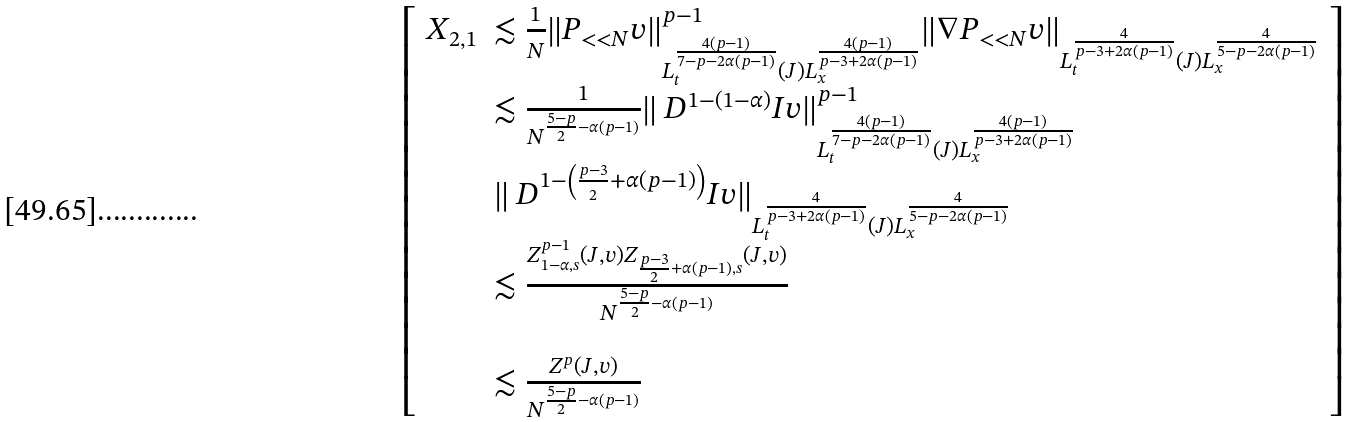Convert formula to latex. <formula><loc_0><loc_0><loc_500><loc_500>\left [ \begin{array} { l l } X _ { 2 , 1 } & \lesssim \frac { 1 } { N } \| P _ { < < N } v \| ^ { p - 1 } _ { L _ { t } ^ { \frac { 4 ( p - 1 ) } { 7 - p - 2 \alpha ( p - 1 ) } } ( J ) L _ { x } ^ { \frac { 4 ( p - 1 ) } { p - 3 + 2 \alpha ( p - 1 ) } } } \| \nabla P _ { < < N } v \| _ { L _ { t } ^ { \frac { 4 } { p - 3 + 2 \alpha ( p - 1 ) } } ( J ) L _ { x } ^ { \frac { 4 } { 5 - p - 2 \alpha ( p - 1 ) } } } \\ & \lesssim \frac { 1 } { N ^ { \frac { 5 - p } { 2 } - \alpha ( p - 1 ) } } \| \ D ^ { 1 - ( 1 - \alpha ) } I v \| ^ { p - 1 } _ { L _ { t } ^ { \frac { 4 ( p - 1 ) } { 7 - p - 2 \alpha ( p - 1 ) } } ( J ) L _ { x } ^ { \frac { 4 ( p - 1 ) } { p - 3 + 2 \alpha ( p - 1 ) } } } \\ & \| \ D ^ { 1 - \left ( \frac { p - 3 } { 2 } + \alpha ( p - 1 ) \right ) } I v \| _ { L _ { t } ^ { \frac { 4 } { p - 3 + 2 \alpha ( p - 1 ) } } ( J ) L _ { x } ^ { \frac { 4 } { 5 - p - 2 \alpha ( p - 1 ) } } } \\ & \lesssim \frac { Z ^ { p - 1 } _ { 1 - \alpha , s } ( J , v ) Z _ { \frac { p - 3 } { 2 } + \alpha ( p - 1 ) , s } ( J , v ) } { N ^ { \frac { 5 - p } { 2 } - \alpha ( p - 1 ) } } \\ & \\ & \lesssim \frac { Z ^ { p } ( J , v ) } { N ^ { \frac { 5 - p } { 2 } - \alpha ( p - 1 ) } } \end{array} \right ]</formula> 